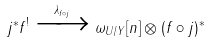<formula> <loc_0><loc_0><loc_500><loc_500>j ^ { \ast } f ^ { ! } \xrightarrow { \lambda _ { f \circ j } } \omega _ { U / Y } [ n ] \otimes ( f \circ j ) ^ { \ast }</formula> 